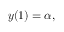Convert formula to latex. <formula><loc_0><loc_0><loc_500><loc_500>y ( 1 ) = \alpha ,</formula> 